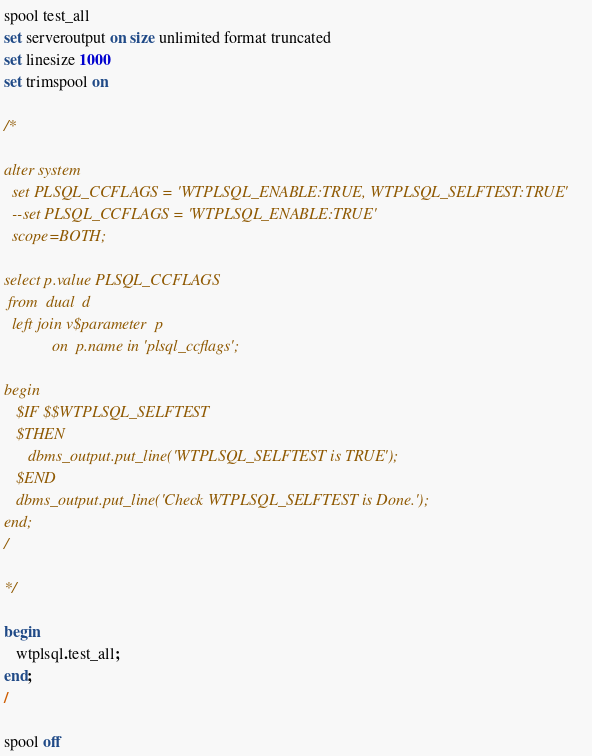<code> <loc_0><loc_0><loc_500><loc_500><_SQL_>
spool test_all
set serveroutput on size unlimited format truncated
set linesize 1000
set trimspool on

/*

alter system
  set PLSQL_CCFLAGS = 'WTPLSQL_ENABLE:TRUE, WTPLSQL_SELFTEST:TRUE'
  --set PLSQL_CCFLAGS = 'WTPLSQL_ENABLE:TRUE'
  scope=BOTH;

select p.value PLSQL_CCFLAGS
 from  dual  d
  left join v$parameter  p
            on  p.name in 'plsql_ccflags';

begin
   $IF $$WTPLSQL_SELFTEST
   $THEN
      dbms_output.put_line('WTPLSQL_SELFTEST is TRUE');
   $END
   dbms_output.put_line('Check WTPLSQL_SELFTEST is Done.');
end;
/

*/

begin
   wtplsql.test_all;
end;
/

spool off
</code> 